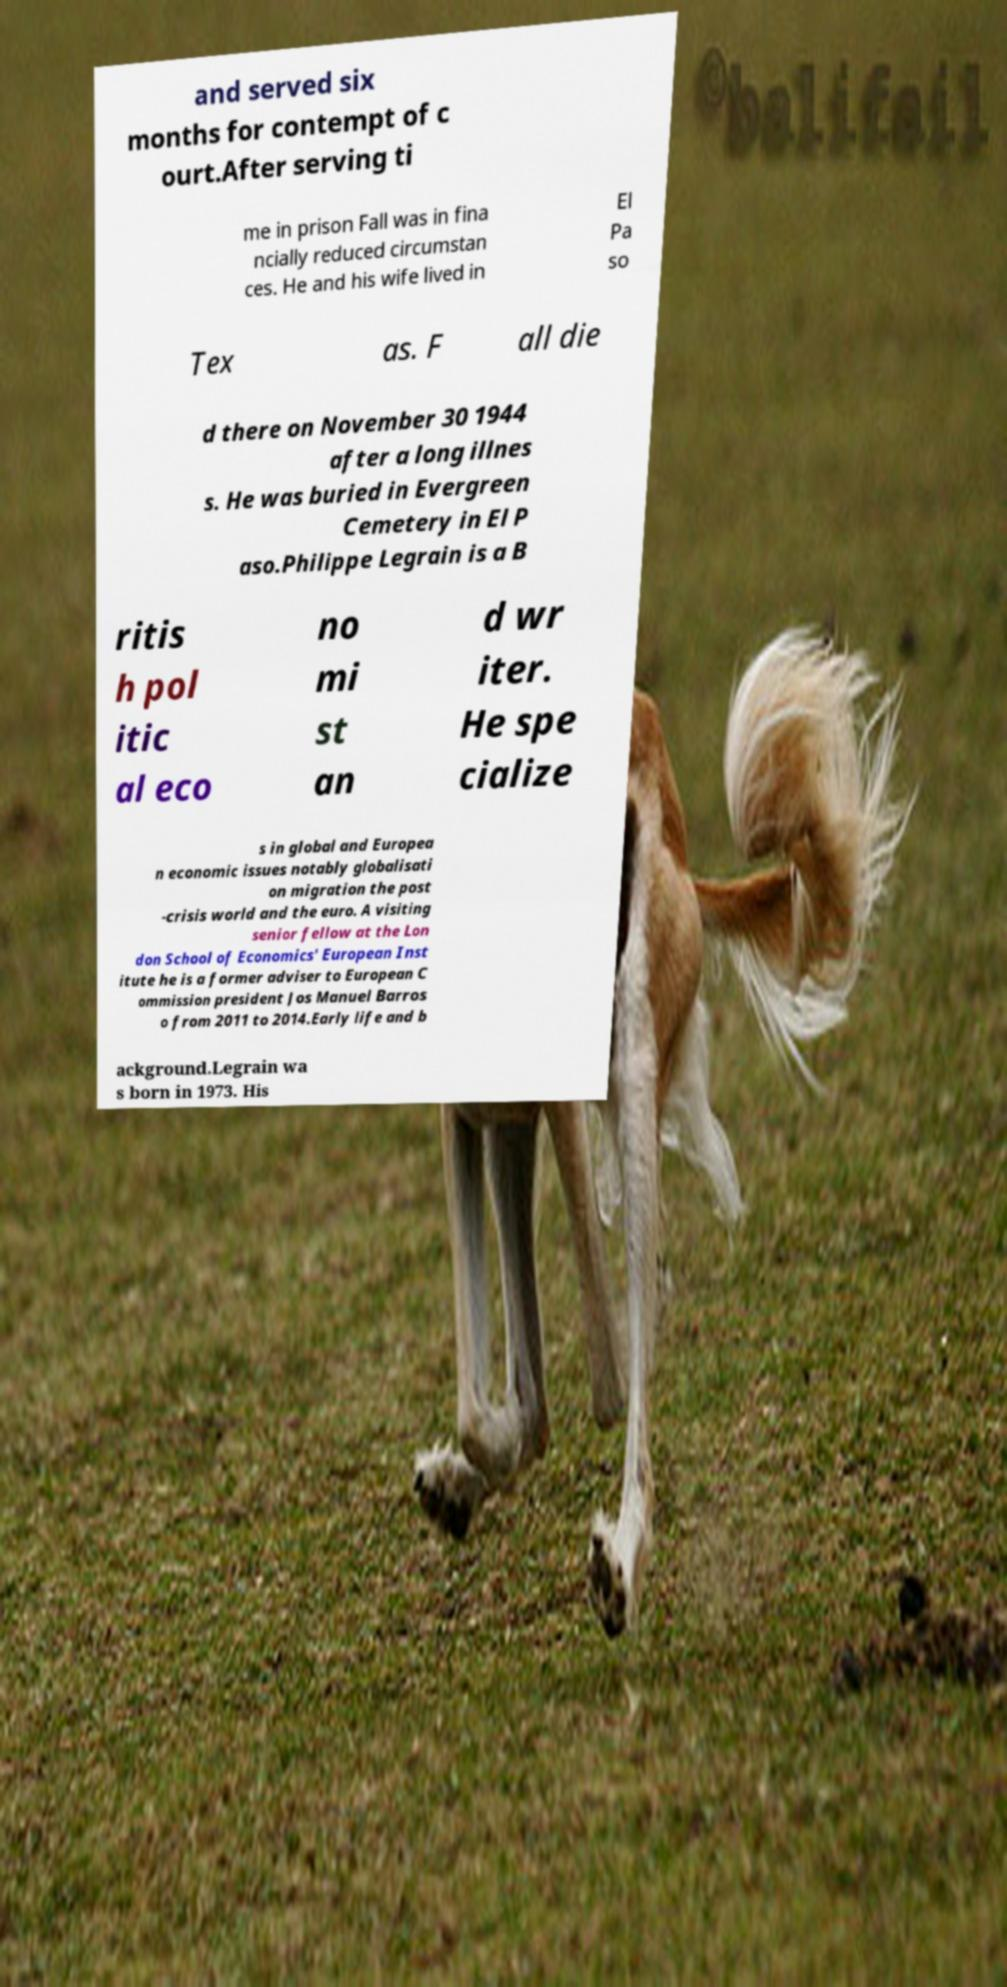For documentation purposes, I need the text within this image transcribed. Could you provide that? and served six months for contempt of c ourt.After serving ti me in prison Fall was in fina ncially reduced circumstan ces. He and his wife lived in El Pa so Tex as. F all die d there on November 30 1944 after a long illnes s. He was buried in Evergreen Cemetery in El P aso.Philippe Legrain is a B ritis h pol itic al eco no mi st an d wr iter. He spe cialize s in global and Europea n economic issues notably globalisati on migration the post -crisis world and the euro. A visiting senior fellow at the Lon don School of Economics' European Inst itute he is a former adviser to European C ommission president Jos Manuel Barros o from 2011 to 2014.Early life and b ackground.Legrain wa s born in 1973. His 